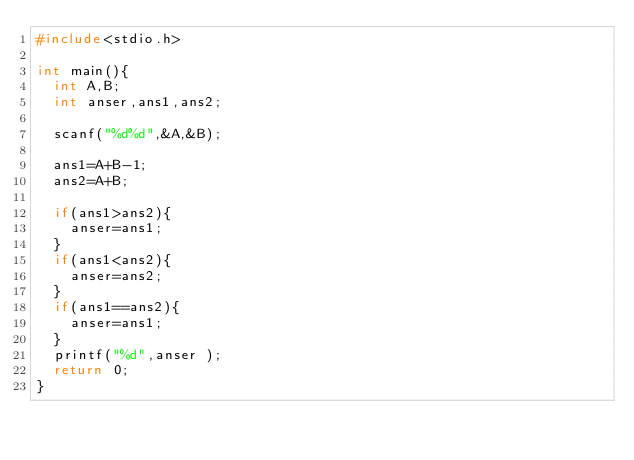Convert code to text. <code><loc_0><loc_0><loc_500><loc_500><_C_>#include<stdio.h>

int main(){
	int A,B;
	int anser,ans1,ans2;

	scanf("%d%d",&A,&B);
	
	ans1=A+B-1;
	ans2=A+B;

	if(ans1>ans2){
		anser=ans1;
	}
	if(ans1<ans2){
		anser=ans2;
	}
	if(ans1==ans2){
		anser=ans1;
	}
	printf("%d",anser );
	return 0;
}</code> 